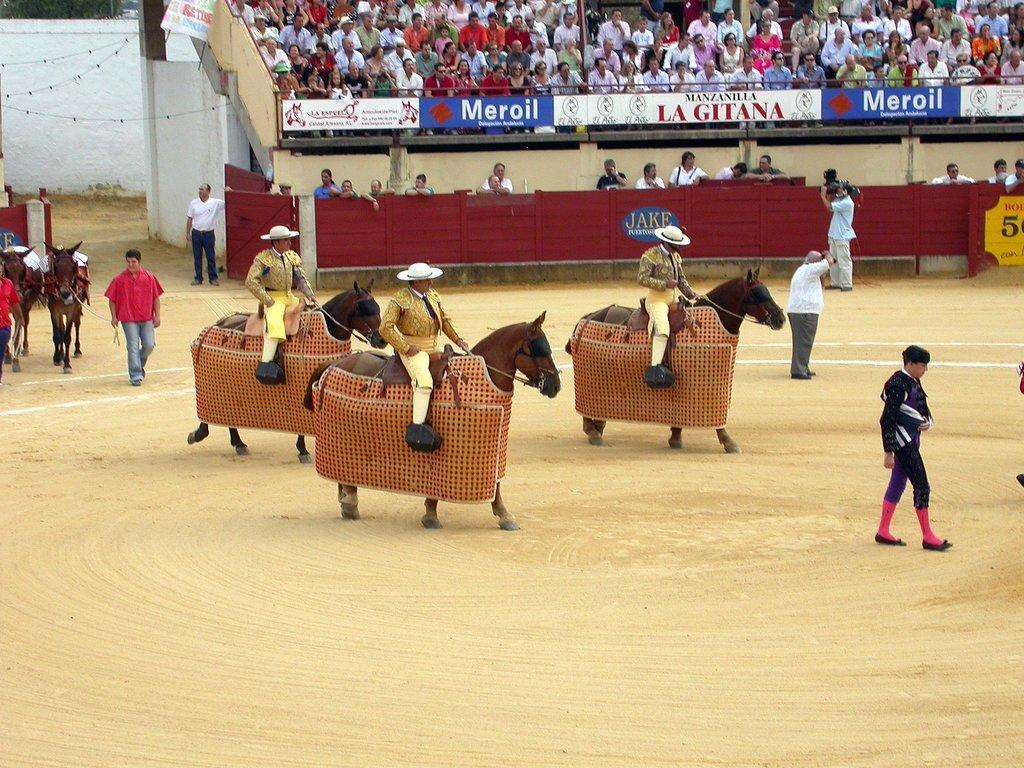Can you describe this image briefly? In this image there are horses on a ground, on that horses there are three men are sitting and people are standing on the ground, in the background there are people sitting on chairs and there is a board on that board there is some text. 